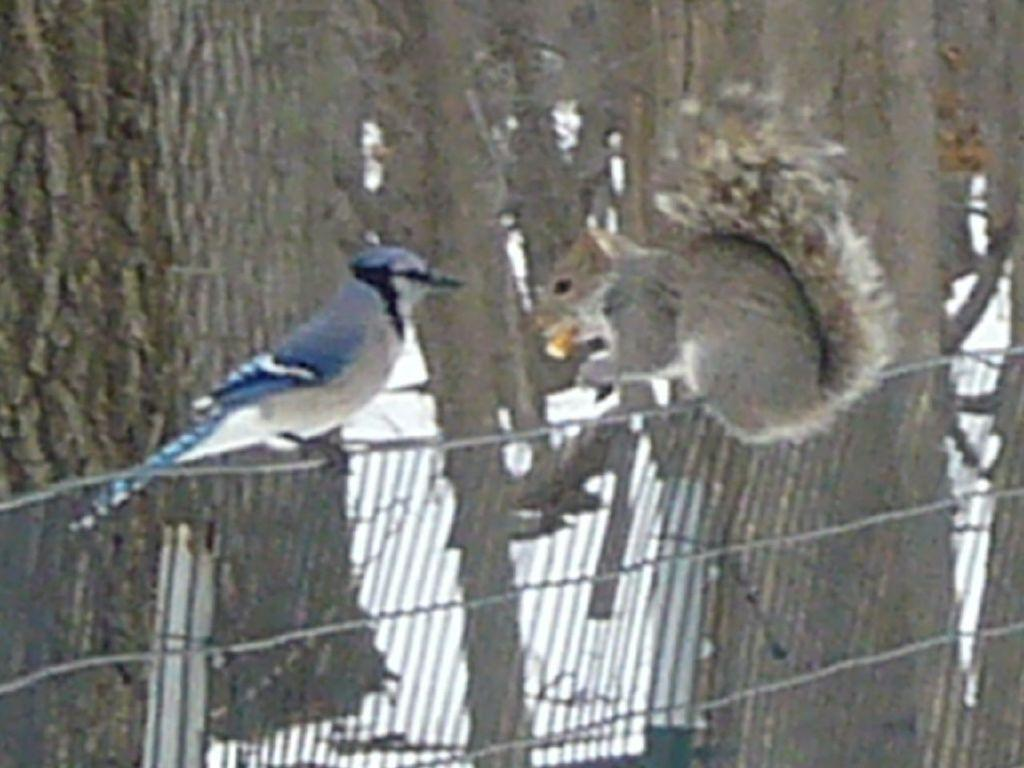What type of animal can be seen in the image? There is a bird in the image. Where is the bird located? The bird is standing on a fence. What can be seen in the background of the image? There are other objects in the background of the image. How many sisters does the bird have in the image? There are no sisters mentioned or depicted in the image, as it features a bird standing on a fence. 